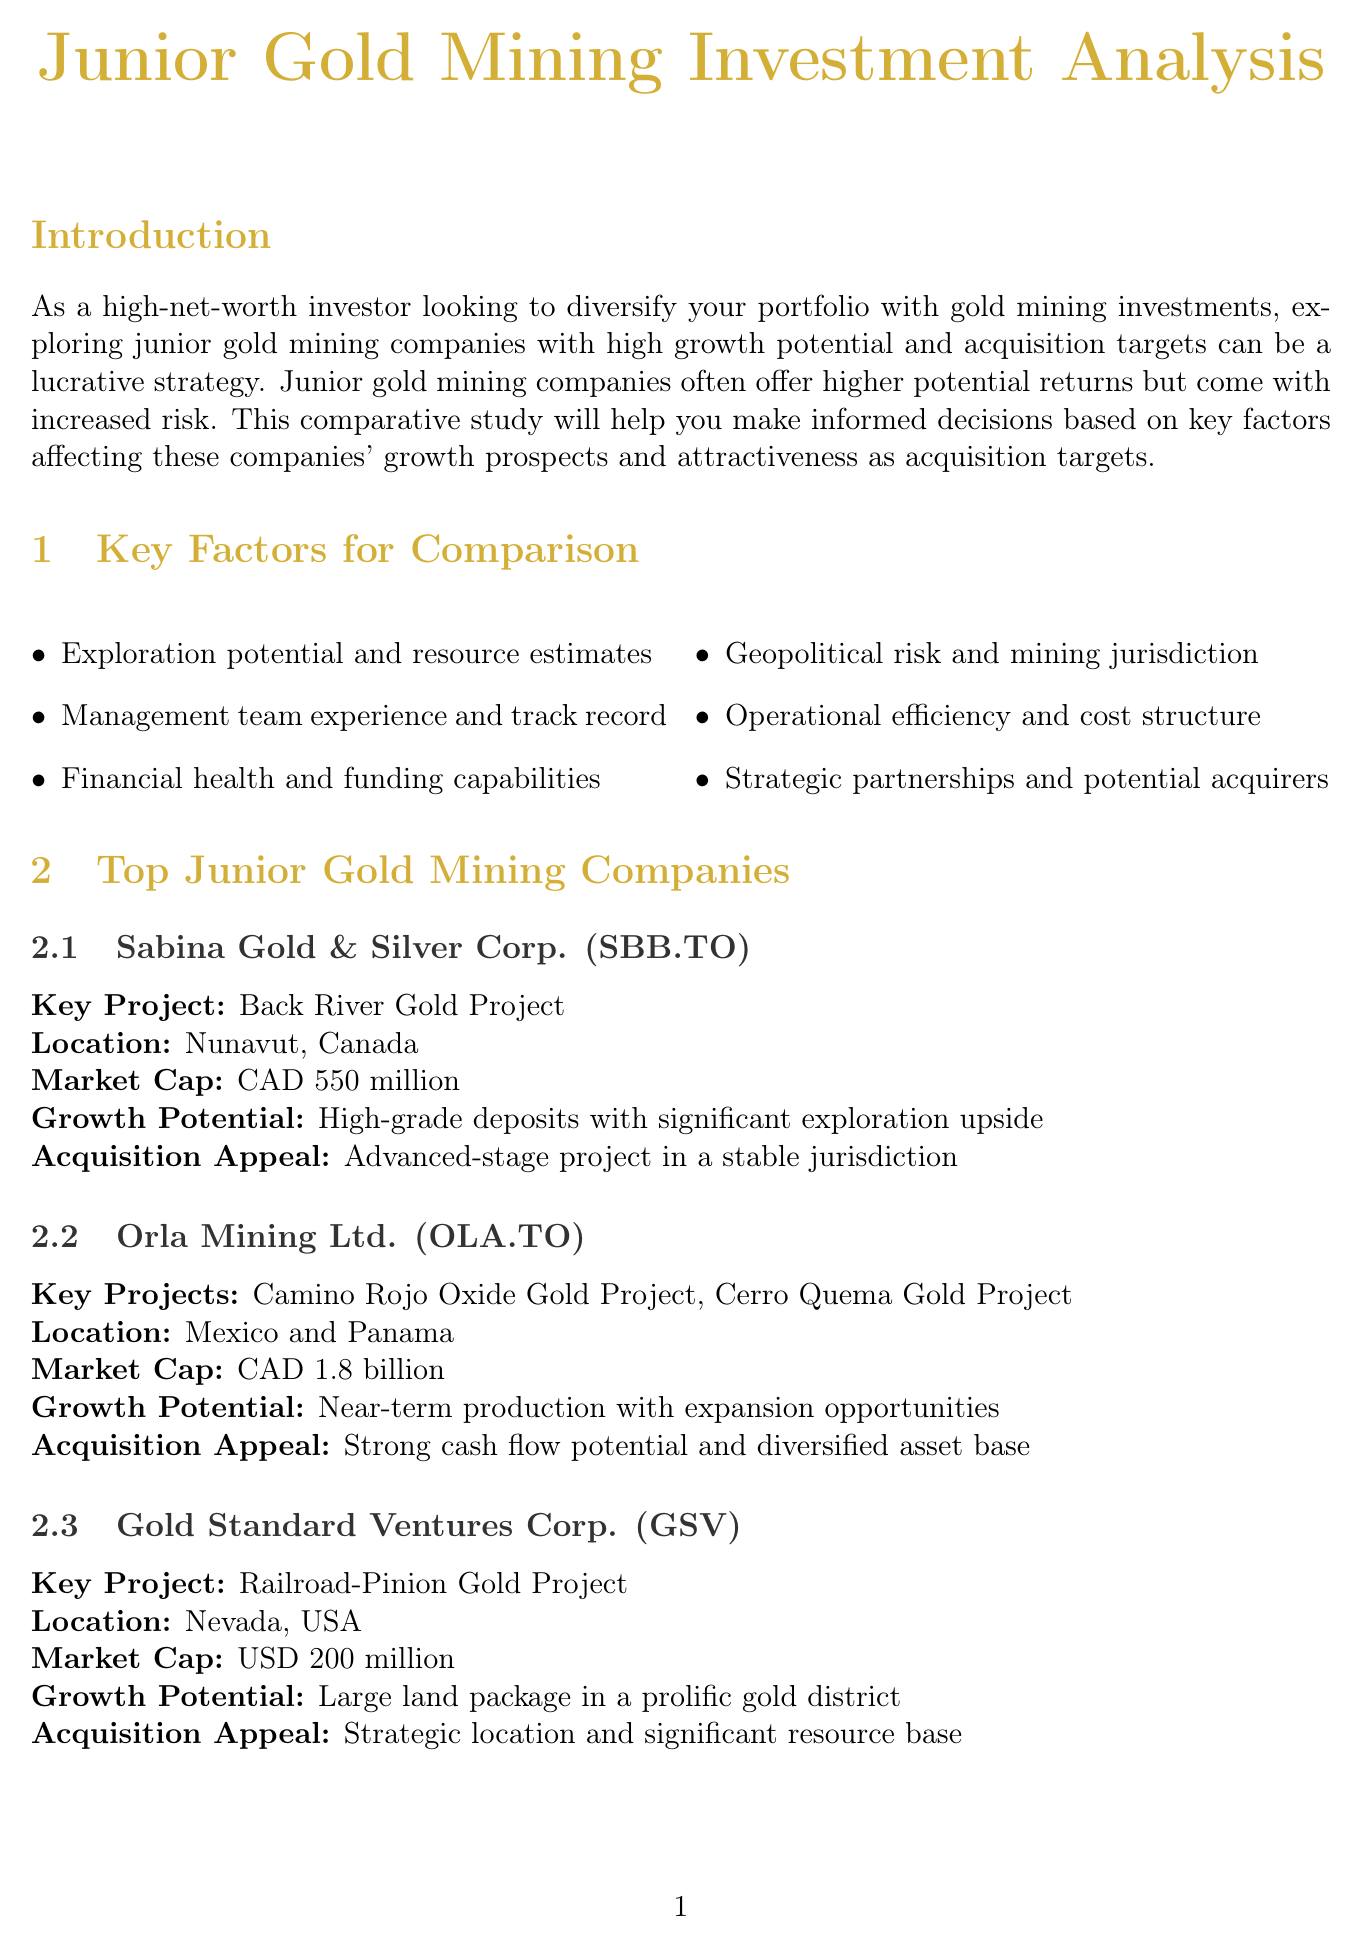What is the market cap of Sabina Gold & Silver Corp.? The market cap is provided in the document under the section for top junior gold mining companies.
Answer: CAD 550 million What is the key project of Gold Standard Ventures Corp.? The key project is listed in the company’s profile section in the document.
Answer: Railroad-Pinion Gold Project Which financial metrics are crucial for assessing companies? The document lists several metrics in the financial analysis section that are important.
Answer: Price-to-Net Asset Value, Enterprise Value to Resources, Debt-to-Equity Ratio, Cash position and burn rate What are the geopolitical risk factors mentioned? The document enumerates specific factors relevant to geopolitical risk assessment in mining.
Answer: Mining code stability, Tax regime, Environmental regulations, Local community relations What is one acquisition appeal of Orla Mining Ltd.? The acquisition appeal is a characteristic summarized in the section discussing key junior mining companies.
Answer: Strong cash flow potential and diversified asset base Which strategy focuses on companies with significant exploration potential? The investment strategies outlined in the document detail different approaches for investors.
Answer: Exploration upside Who is interested in large-scale deposits in stable jurisdictions? The document mentions potential acquirers and their interests in the mining sector.
Answer: Barrick Gold Corporation Which junior gold mining company has a high-grade deposit with significant exploration upside? The growth potential attributes for companies are specified in their profiles.
Answer: Sabina Gold & Silver Corp 